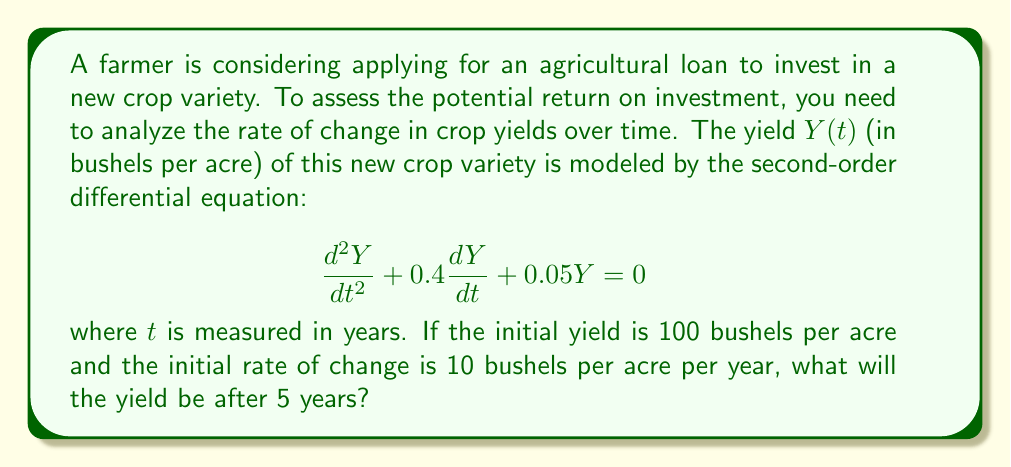Help me with this question. To solve this problem, we need to follow these steps:

1) First, we recognize this as a second-order linear homogeneous differential equation with constant coefficients. The characteristic equation is:

   $$r^2 + 0.4r + 0.05 = 0$$

2) Solving this quadratic equation:
   $$r = \frac{-0.4 \pm \sqrt{0.4^2 - 4(1)(0.05)}}{2(1)} = \frac{-0.4 \pm \sqrt{0.16 - 0.2}}{2} = \frac{-0.4 \pm \sqrt{-0.04}}{2}$$

3) This gives us complex roots: $r = -0.2 \pm 0.1i$

4) The general solution is therefore:
   $$Y(t) = e^{-0.2t}(C_1\cos(0.1t) + C_2\sin(0.1t))$$

5) We need to use the initial conditions to find $C_1$ and $C_2$:
   - $Y(0) = 100$, so $C_1 = 100$
   - $Y'(0) = 10$, so $-0.2C_1 + 0.1C_2 = 10$

6) From the second condition:
   $-0.2(100) + 0.1C_2 = 10$
   $0.1C_2 = 30$
   $C_2 = 300$

7) Therefore, the particular solution is:
   $$Y(t) = e^{-0.2t}(100\cos(0.1t) + 300\sin(0.1t))$$

8) To find the yield after 5 years, we evaluate $Y(5)$:
   $$Y(5) = e^{-0.2(5)}(100\cos(0.1(5)) + 300\sin(0.1(5)))$$
   $$= e^{-1}(100\cos(0.5) + 300\sin(0.5))$$
   $$\approx 0.368 * (87.76 + 143.13) = 85.16$$
Answer: The yield after 5 years will be approximately 85.16 bushels per acre. 